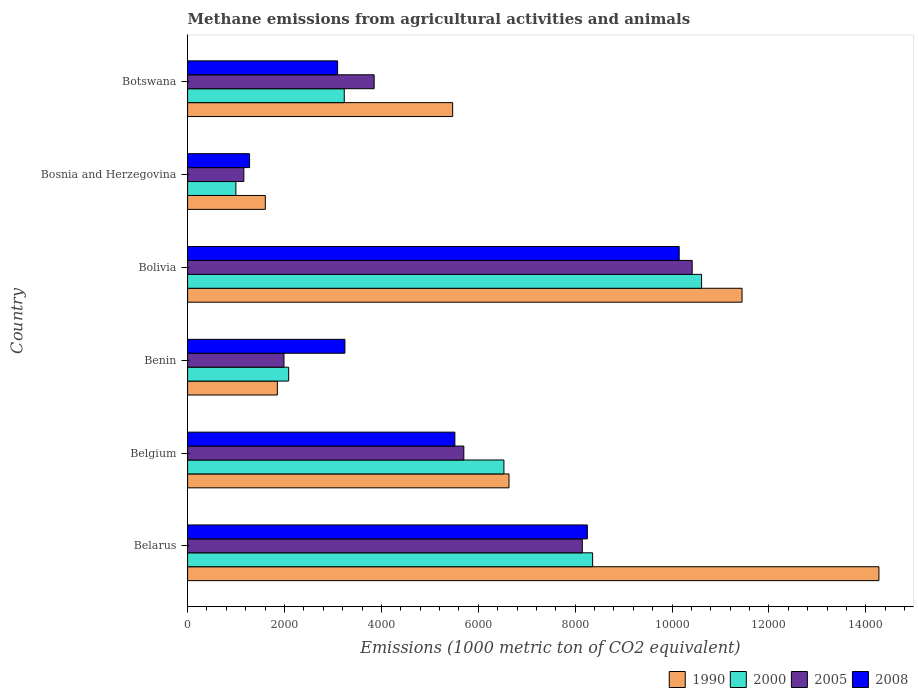Are the number of bars on each tick of the Y-axis equal?
Provide a short and direct response. Yes. How many bars are there on the 4th tick from the top?
Offer a very short reply. 4. What is the label of the 5th group of bars from the top?
Provide a succinct answer. Belgium. In how many cases, is the number of bars for a given country not equal to the number of legend labels?
Provide a succinct answer. 0. What is the amount of methane emitted in 2005 in Belarus?
Your response must be concise. 8147.7. Across all countries, what is the maximum amount of methane emitted in 2008?
Offer a terse response. 1.01e+04. Across all countries, what is the minimum amount of methane emitted in 2008?
Offer a very short reply. 1279.4. In which country was the amount of methane emitted in 1990 maximum?
Provide a short and direct response. Belarus. In which country was the amount of methane emitted in 2008 minimum?
Your response must be concise. Bosnia and Herzegovina. What is the total amount of methane emitted in 1990 in the graph?
Make the answer very short. 4.13e+04. What is the difference between the amount of methane emitted in 1990 in Benin and that in Bolivia?
Provide a succinct answer. -9592. What is the difference between the amount of methane emitted in 1990 in Bolivia and the amount of methane emitted in 2005 in Belgium?
Keep it short and to the point. 5743.2. What is the average amount of methane emitted in 2005 per country?
Your answer should be compact. 5211.05. What is the difference between the amount of methane emitted in 2005 and amount of methane emitted in 1990 in Belarus?
Ensure brevity in your answer.  -6122.6. What is the ratio of the amount of methane emitted in 2008 in Bolivia to that in Botswana?
Your answer should be compact. 3.28. Is the amount of methane emitted in 2008 in Belarus less than that in Bosnia and Herzegovina?
Your answer should be very brief. No. What is the difference between the highest and the second highest amount of methane emitted in 2008?
Your response must be concise. 1895.5. What is the difference between the highest and the lowest amount of methane emitted in 1990?
Your response must be concise. 1.27e+04. In how many countries, is the amount of methane emitted in 1990 greater than the average amount of methane emitted in 1990 taken over all countries?
Provide a succinct answer. 2. Is the sum of the amount of methane emitted in 1990 in Belarus and Belgium greater than the maximum amount of methane emitted in 2000 across all countries?
Offer a very short reply. Yes. What does the 3rd bar from the bottom in Benin represents?
Give a very brief answer. 2005. Is it the case that in every country, the sum of the amount of methane emitted in 2000 and amount of methane emitted in 1990 is greater than the amount of methane emitted in 2008?
Keep it short and to the point. Yes. How many countries are there in the graph?
Provide a succinct answer. 6. What is the difference between two consecutive major ticks on the X-axis?
Your answer should be compact. 2000. Does the graph contain any zero values?
Keep it short and to the point. No. Where does the legend appear in the graph?
Offer a very short reply. Bottom right. How are the legend labels stacked?
Offer a very short reply. Horizontal. What is the title of the graph?
Offer a very short reply. Methane emissions from agricultural activities and animals. Does "1980" appear as one of the legend labels in the graph?
Your answer should be very brief. No. What is the label or title of the X-axis?
Offer a terse response. Emissions (1000 metric ton of CO2 equivalent). What is the label or title of the Y-axis?
Your response must be concise. Country. What is the Emissions (1000 metric ton of CO2 equivalent) in 1990 in Belarus?
Keep it short and to the point. 1.43e+04. What is the Emissions (1000 metric ton of CO2 equivalent) of 2000 in Belarus?
Your answer should be very brief. 8360.4. What is the Emissions (1000 metric ton of CO2 equivalent) in 2005 in Belarus?
Offer a very short reply. 8147.7. What is the Emissions (1000 metric ton of CO2 equivalent) in 2008 in Belarus?
Your response must be concise. 8252. What is the Emissions (1000 metric ton of CO2 equivalent) of 1990 in Belgium?
Your answer should be very brief. 6634.3. What is the Emissions (1000 metric ton of CO2 equivalent) of 2000 in Belgium?
Offer a terse response. 6529.5. What is the Emissions (1000 metric ton of CO2 equivalent) in 2005 in Belgium?
Your response must be concise. 5701.8. What is the Emissions (1000 metric ton of CO2 equivalent) in 2008 in Belgium?
Give a very brief answer. 5517.1. What is the Emissions (1000 metric ton of CO2 equivalent) of 1990 in Benin?
Your answer should be very brief. 1853. What is the Emissions (1000 metric ton of CO2 equivalent) of 2000 in Benin?
Offer a very short reply. 2086.3. What is the Emissions (1000 metric ton of CO2 equivalent) in 2005 in Benin?
Your answer should be very brief. 1989.2. What is the Emissions (1000 metric ton of CO2 equivalent) of 2008 in Benin?
Ensure brevity in your answer.  3247.6. What is the Emissions (1000 metric ton of CO2 equivalent) of 1990 in Bolivia?
Offer a terse response. 1.14e+04. What is the Emissions (1000 metric ton of CO2 equivalent) in 2000 in Bolivia?
Give a very brief answer. 1.06e+04. What is the Emissions (1000 metric ton of CO2 equivalent) in 2005 in Bolivia?
Offer a very short reply. 1.04e+04. What is the Emissions (1000 metric ton of CO2 equivalent) in 2008 in Bolivia?
Keep it short and to the point. 1.01e+04. What is the Emissions (1000 metric ton of CO2 equivalent) of 1990 in Bosnia and Herzegovina?
Give a very brief answer. 1604.3. What is the Emissions (1000 metric ton of CO2 equivalent) of 2000 in Bosnia and Herzegovina?
Provide a succinct answer. 996.6. What is the Emissions (1000 metric ton of CO2 equivalent) in 2005 in Bosnia and Herzegovina?
Offer a very short reply. 1161.2. What is the Emissions (1000 metric ton of CO2 equivalent) of 2008 in Bosnia and Herzegovina?
Offer a terse response. 1279.4. What is the Emissions (1000 metric ton of CO2 equivalent) of 1990 in Botswana?
Your answer should be very brief. 5471.2. What is the Emissions (1000 metric ton of CO2 equivalent) in 2000 in Botswana?
Give a very brief answer. 3234. What is the Emissions (1000 metric ton of CO2 equivalent) in 2005 in Botswana?
Your response must be concise. 3850.6. What is the Emissions (1000 metric ton of CO2 equivalent) of 2008 in Botswana?
Make the answer very short. 3096.4. Across all countries, what is the maximum Emissions (1000 metric ton of CO2 equivalent) in 1990?
Your answer should be compact. 1.43e+04. Across all countries, what is the maximum Emissions (1000 metric ton of CO2 equivalent) in 2000?
Ensure brevity in your answer.  1.06e+04. Across all countries, what is the maximum Emissions (1000 metric ton of CO2 equivalent) in 2005?
Keep it short and to the point. 1.04e+04. Across all countries, what is the maximum Emissions (1000 metric ton of CO2 equivalent) in 2008?
Keep it short and to the point. 1.01e+04. Across all countries, what is the minimum Emissions (1000 metric ton of CO2 equivalent) of 1990?
Offer a very short reply. 1604.3. Across all countries, what is the minimum Emissions (1000 metric ton of CO2 equivalent) in 2000?
Keep it short and to the point. 996.6. Across all countries, what is the minimum Emissions (1000 metric ton of CO2 equivalent) in 2005?
Provide a succinct answer. 1161.2. Across all countries, what is the minimum Emissions (1000 metric ton of CO2 equivalent) in 2008?
Keep it short and to the point. 1279.4. What is the total Emissions (1000 metric ton of CO2 equivalent) of 1990 in the graph?
Provide a short and direct response. 4.13e+04. What is the total Emissions (1000 metric ton of CO2 equivalent) in 2000 in the graph?
Your answer should be very brief. 3.18e+04. What is the total Emissions (1000 metric ton of CO2 equivalent) of 2005 in the graph?
Provide a succinct answer. 3.13e+04. What is the total Emissions (1000 metric ton of CO2 equivalent) in 2008 in the graph?
Make the answer very short. 3.15e+04. What is the difference between the Emissions (1000 metric ton of CO2 equivalent) in 1990 in Belarus and that in Belgium?
Provide a short and direct response. 7636. What is the difference between the Emissions (1000 metric ton of CO2 equivalent) in 2000 in Belarus and that in Belgium?
Offer a very short reply. 1830.9. What is the difference between the Emissions (1000 metric ton of CO2 equivalent) in 2005 in Belarus and that in Belgium?
Your response must be concise. 2445.9. What is the difference between the Emissions (1000 metric ton of CO2 equivalent) of 2008 in Belarus and that in Belgium?
Your answer should be compact. 2734.9. What is the difference between the Emissions (1000 metric ton of CO2 equivalent) in 1990 in Belarus and that in Benin?
Make the answer very short. 1.24e+04. What is the difference between the Emissions (1000 metric ton of CO2 equivalent) of 2000 in Belarus and that in Benin?
Ensure brevity in your answer.  6274.1. What is the difference between the Emissions (1000 metric ton of CO2 equivalent) of 2005 in Belarus and that in Benin?
Make the answer very short. 6158.5. What is the difference between the Emissions (1000 metric ton of CO2 equivalent) in 2008 in Belarus and that in Benin?
Provide a succinct answer. 5004.4. What is the difference between the Emissions (1000 metric ton of CO2 equivalent) in 1990 in Belarus and that in Bolivia?
Ensure brevity in your answer.  2825.3. What is the difference between the Emissions (1000 metric ton of CO2 equivalent) in 2000 in Belarus and that in Bolivia?
Your answer should be compact. -2249.3. What is the difference between the Emissions (1000 metric ton of CO2 equivalent) in 2005 in Belarus and that in Bolivia?
Ensure brevity in your answer.  -2268.1. What is the difference between the Emissions (1000 metric ton of CO2 equivalent) of 2008 in Belarus and that in Bolivia?
Keep it short and to the point. -1895.5. What is the difference between the Emissions (1000 metric ton of CO2 equivalent) in 1990 in Belarus and that in Bosnia and Herzegovina?
Make the answer very short. 1.27e+04. What is the difference between the Emissions (1000 metric ton of CO2 equivalent) of 2000 in Belarus and that in Bosnia and Herzegovina?
Offer a terse response. 7363.8. What is the difference between the Emissions (1000 metric ton of CO2 equivalent) of 2005 in Belarus and that in Bosnia and Herzegovina?
Offer a very short reply. 6986.5. What is the difference between the Emissions (1000 metric ton of CO2 equivalent) in 2008 in Belarus and that in Bosnia and Herzegovina?
Your response must be concise. 6972.6. What is the difference between the Emissions (1000 metric ton of CO2 equivalent) of 1990 in Belarus and that in Botswana?
Your answer should be very brief. 8799.1. What is the difference between the Emissions (1000 metric ton of CO2 equivalent) in 2000 in Belarus and that in Botswana?
Your answer should be very brief. 5126.4. What is the difference between the Emissions (1000 metric ton of CO2 equivalent) of 2005 in Belarus and that in Botswana?
Your response must be concise. 4297.1. What is the difference between the Emissions (1000 metric ton of CO2 equivalent) of 2008 in Belarus and that in Botswana?
Provide a succinct answer. 5155.6. What is the difference between the Emissions (1000 metric ton of CO2 equivalent) of 1990 in Belgium and that in Benin?
Keep it short and to the point. 4781.3. What is the difference between the Emissions (1000 metric ton of CO2 equivalent) in 2000 in Belgium and that in Benin?
Ensure brevity in your answer.  4443.2. What is the difference between the Emissions (1000 metric ton of CO2 equivalent) of 2005 in Belgium and that in Benin?
Your response must be concise. 3712.6. What is the difference between the Emissions (1000 metric ton of CO2 equivalent) of 2008 in Belgium and that in Benin?
Give a very brief answer. 2269.5. What is the difference between the Emissions (1000 metric ton of CO2 equivalent) of 1990 in Belgium and that in Bolivia?
Your response must be concise. -4810.7. What is the difference between the Emissions (1000 metric ton of CO2 equivalent) of 2000 in Belgium and that in Bolivia?
Make the answer very short. -4080.2. What is the difference between the Emissions (1000 metric ton of CO2 equivalent) in 2005 in Belgium and that in Bolivia?
Give a very brief answer. -4714. What is the difference between the Emissions (1000 metric ton of CO2 equivalent) of 2008 in Belgium and that in Bolivia?
Provide a succinct answer. -4630.4. What is the difference between the Emissions (1000 metric ton of CO2 equivalent) of 1990 in Belgium and that in Bosnia and Herzegovina?
Ensure brevity in your answer.  5030. What is the difference between the Emissions (1000 metric ton of CO2 equivalent) in 2000 in Belgium and that in Bosnia and Herzegovina?
Provide a succinct answer. 5532.9. What is the difference between the Emissions (1000 metric ton of CO2 equivalent) of 2005 in Belgium and that in Bosnia and Herzegovina?
Provide a succinct answer. 4540.6. What is the difference between the Emissions (1000 metric ton of CO2 equivalent) of 2008 in Belgium and that in Bosnia and Herzegovina?
Provide a succinct answer. 4237.7. What is the difference between the Emissions (1000 metric ton of CO2 equivalent) in 1990 in Belgium and that in Botswana?
Your answer should be very brief. 1163.1. What is the difference between the Emissions (1000 metric ton of CO2 equivalent) in 2000 in Belgium and that in Botswana?
Keep it short and to the point. 3295.5. What is the difference between the Emissions (1000 metric ton of CO2 equivalent) of 2005 in Belgium and that in Botswana?
Your answer should be compact. 1851.2. What is the difference between the Emissions (1000 metric ton of CO2 equivalent) of 2008 in Belgium and that in Botswana?
Make the answer very short. 2420.7. What is the difference between the Emissions (1000 metric ton of CO2 equivalent) in 1990 in Benin and that in Bolivia?
Provide a succinct answer. -9592. What is the difference between the Emissions (1000 metric ton of CO2 equivalent) in 2000 in Benin and that in Bolivia?
Your answer should be compact. -8523.4. What is the difference between the Emissions (1000 metric ton of CO2 equivalent) of 2005 in Benin and that in Bolivia?
Give a very brief answer. -8426.6. What is the difference between the Emissions (1000 metric ton of CO2 equivalent) in 2008 in Benin and that in Bolivia?
Give a very brief answer. -6899.9. What is the difference between the Emissions (1000 metric ton of CO2 equivalent) of 1990 in Benin and that in Bosnia and Herzegovina?
Your response must be concise. 248.7. What is the difference between the Emissions (1000 metric ton of CO2 equivalent) in 2000 in Benin and that in Bosnia and Herzegovina?
Your answer should be very brief. 1089.7. What is the difference between the Emissions (1000 metric ton of CO2 equivalent) of 2005 in Benin and that in Bosnia and Herzegovina?
Make the answer very short. 828. What is the difference between the Emissions (1000 metric ton of CO2 equivalent) in 2008 in Benin and that in Bosnia and Herzegovina?
Provide a succinct answer. 1968.2. What is the difference between the Emissions (1000 metric ton of CO2 equivalent) of 1990 in Benin and that in Botswana?
Offer a very short reply. -3618.2. What is the difference between the Emissions (1000 metric ton of CO2 equivalent) in 2000 in Benin and that in Botswana?
Keep it short and to the point. -1147.7. What is the difference between the Emissions (1000 metric ton of CO2 equivalent) of 2005 in Benin and that in Botswana?
Provide a succinct answer. -1861.4. What is the difference between the Emissions (1000 metric ton of CO2 equivalent) of 2008 in Benin and that in Botswana?
Ensure brevity in your answer.  151.2. What is the difference between the Emissions (1000 metric ton of CO2 equivalent) of 1990 in Bolivia and that in Bosnia and Herzegovina?
Your answer should be compact. 9840.7. What is the difference between the Emissions (1000 metric ton of CO2 equivalent) of 2000 in Bolivia and that in Bosnia and Herzegovina?
Provide a succinct answer. 9613.1. What is the difference between the Emissions (1000 metric ton of CO2 equivalent) in 2005 in Bolivia and that in Bosnia and Herzegovina?
Ensure brevity in your answer.  9254.6. What is the difference between the Emissions (1000 metric ton of CO2 equivalent) in 2008 in Bolivia and that in Bosnia and Herzegovina?
Give a very brief answer. 8868.1. What is the difference between the Emissions (1000 metric ton of CO2 equivalent) in 1990 in Bolivia and that in Botswana?
Your response must be concise. 5973.8. What is the difference between the Emissions (1000 metric ton of CO2 equivalent) in 2000 in Bolivia and that in Botswana?
Ensure brevity in your answer.  7375.7. What is the difference between the Emissions (1000 metric ton of CO2 equivalent) in 2005 in Bolivia and that in Botswana?
Your answer should be very brief. 6565.2. What is the difference between the Emissions (1000 metric ton of CO2 equivalent) in 2008 in Bolivia and that in Botswana?
Provide a short and direct response. 7051.1. What is the difference between the Emissions (1000 metric ton of CO2 equivalent) of 1990 in Bosnia and Herzegovina and that in Botswana?
Ensure brevity in your answer.  -3866.9. What is the difference between the Emissions (1000 metric ton of CO2 equivalent) of 2000 in Bosnia and Herzegovina and that in Botswana?
Ensure brevity in your answer.  -2237.4. What is the difference between the Emissions (1000 metric ton of CO2 equivalent) in 2005 in Bosnia and Herzegovina and that in Botswana?
Keep it short and to the point. -2689.4. What is the difference between the Emissions (1000 metric ton of CO2 equivalent) of 2008 in Bosnia and Herzegovina and that in Botswana?
Your response must be concise. -1817. What is the difference between the Emissions (1000 metric ton of CO2 equivalent) in 1990 in Belarus and the Emissions (1000 metric ton of CO2 equivalent) in 2000 in Belgium?
Make the answer very short. 7740.8. What is the difference between the Emissions (1000 metric ton of CO2 equivalent) of 1990 in Belarus and the Emissions (1000 metric ton of CO2 equivalent) of 2005 in Belgium?
Ensure brevity in your answer.  8568.5. What is the difference between the Emissions (1000 metric ton of CO2 equivalent) of 1990 in Belarus and the Emissions (1000 metric ton of CO2 equivalent) of 2008 in Belgium?
Ensure brevity in your answer.  8753.2. What is the difference between the Emissions (1000 metric ton of CO2 equivalent) in 2000 in Belarus and the Emissions (1000 metric ton of CO2 equivalent) in 2005 in Belgium?
Provide a short and direct response. 2658.6. What is the difference between the Emissions (1000 metric ton of CO2 equivalent) of 2000 in Belarus and the Emissions (1000 metric ton of CO2 equivalent) of 2008 in Belgium?
Give a very brief answer. 2843.3. What is the difference between the Emissions (1000 metric ton of CO2 equivalent) in 2005 in Belarus and the Emissions (1000 metric ton of CO2 equivalent) in 2008 in Belgium?
Keep it short and to the point. 2630.6. What is the difference between the Emissions (1000 metric ton of CO2 equivalent) in 1990 in Belarus and the Emissions (1000 metric ton of CO2 equivalent) in 2000 in Benin?
Give a very brief answer. 1.22e+04. What is the difference between the Emissions (1000 metric ton of CO2 equivalent) in 1990 in Belarus and the Emissions (1000 metric ton of CO2 equivalent) in 2005 in Benin?
Ensure brevity in your answer.  1.23e+04. What is the difference between the Emissions (1000 metric ton of CO2 equivalent) in 1990 in Belarus and the Emissions (1000 metric ton of CO2 equivalent) in 2008 in Benin?
Your answer should be very brief. 1.10e+04. What is the difference between the Emissions (1000 metric ton of CO2 equivalent) of 2000 in Belarus and the Emissions (1000 metric ton of CO2 equivalent) of 2005 in Benin?
Make the answer very short. 6371.2. What is the difference between the Emissions (1000 metric ton of CO2 equivalent) of 2000 in Belarus and the Emissions (1000 metric ton of CO2 equivalent) of 2008 in Benin?
Offer a terse response. 5112.8. What is the difference between the Emissions (1000 metric ton of CO2 equivalent) of 2005 in Belarus and the Emissions (1000 metric ton of CO2 equivalent) of 2008 in Benin?
Your answer should be very brief. 4900.1. What is the difference between the Emissions (1000 metric ton of CO2 equivalent) of 1990 in Belarus and the Emissions (1000 metric ton of CO2 equivalent) of 2000 in Bolivia?
Offer a terse response. 3660.6. What is the difference between the Emissions (1000 metric ton of CO2 equivalent) in 1990 in Belarus and the Emissions (1000 metric ton of CO2 equivalent) in 2005 in Bolivia?
Make the answer very short. 3854.5. What is the difference between the Emissions (1000 metric ton of CO2 equivalent) in 1990 in Belarus and the Emissions (1000 metric ton of CO2 equivalent) in 2008 in Bolivia?
Give a very brief answer. 4122.8. What is the difference between the Emissions (1000 metric ton of CO2 equivalent) in 2000 in Belarus and the Emissions (1000 metric ton of CO2 equivalent) in 2005 in Bolivia?
Make the answer very short. -2055.4. What is the difference between the Emissions (1000 metric ton of CO2 equivalent) of 2000 in Belarus and the Emissions (1000 metric ton of CO2 equivalent) of 2008 in Bolivia?
Your answer should be very brief. -1787.1. What is the difference between the Emissions (1000 metric ton of CO2 equivalent) of 2005 in Belarus and the Emissions (1000 metric ton of CO2 equivalent) of 2008 in Bolivia?
Make the answer very short. -1999.8. What is the difference between the Emissions (1000 metric ton of CO2 equivalent) in 1990 in Belarus and the Emissions (1000 metric ton of CO2 equivalent) in 2000 in Bosnia and Herzegovina?
Your answer should be very brief. 1.33e+04. What is the difference between the Emissions (1000 metric ton of CO2 equivalent) in 1990 in Belarus and the Emissions (1000 metric ton of CO2 equivalent) in 2005 in Bosnia and Herzegovina?
Provide a short and direct response. 1.31e+04. What is the difference between the Emissions (1000 metric ton of CO2 equivalent) of 1990 in Belarus and the Emissions (1000 metric ton of CO2 equivalent) of 2008 in Bosnia and Herzegovina?
Your answer should be compact. 1.30e+04. What is the difference between the Emissions (1000 metric ton of CO2 equivalent) in 2000 in Belarus and the Emissions (1000 metric ton of CO2 equivalent) in 2005 in Bosnia and Herzegovina?
Your answer should be very brief. 7199.2. What is the difference between the Emissions (1000 metric ton of CO2 equivalent) in 2000 in Belarus and the Emissions (1000 metric ton of CO2 equivalent) in 2008 in Bosnia and Herzegovina?
Your answer should be compact. 7081. What is the difference between the Emissions (1000 metric ton of CO2 equivalent) of 2005 in Belarus and the Emissions (1000 metric ton of CO2 equivalent) of 2008 in Bosnia and Herzegovina?
Keep it short and to the point. 6868.3. What is the difference between the Emissions (1000 metric ton of CO2 equivalent) of 1990 in Belarus and the Emissions (1000 metric ton of CO2 equivalent) of 2000 in Botswana?
Your answer should be very brief. 1.10e+04. What is the difference between the Emissions (1000 metric ton of CO2 equivalent) in 1990 in Belarus and the Emissions (1000 metric ton of CO2 equivalent) in 2005 in Botswana?
Keep it short and to the point. 1.04e+04. What is the difference between the Emissions (1000 metric ton of CO2 equivalent) of 1990 in Belarus and the Emissions (1000 metric ton of CO2 equivalent) of 2008 in Botswana?
Your response must be concise. 1.12e+04. What is the difference between the Emissions (1000 metric ton of CO2 equivalent) in 2000 in Belarus and the Emissions (1000 metric ton of CO2 equivalent) in 2005 in Botswana?
Offer a terse response. 4509.8. What is the difference between the Emissions (1000 metric ton of CO2 equivalent) of 2000 in Belarus and the Emissions (1000 metric ton of CO2 equivalent) of 2008 in Botswana?
Provide a succinct answer. 5264. What is the difference between the Emissions (1000 metric ton of CO2 equivalent) of 2005 in Belarus and the Emissions (1000 metric ton of CO2 equivalent) of 2008 in Botswana?
Give a very brief answer. 5051.3. What is the difference between the Emissions (1000 metric ton of CO2 equivalent) in 1990 in Belgium and the Emissions (1000 metric ton of CO2 equivalent) in 2000 in Benin?
Keep it short and to the point. 4548. What is the difference between the Emissions (1000 metric ton of CO2 equivalent) of 1990 in Belgium and the Emissions (1000 metric ton of CO2 equivalent) of 2005 in Benin?
Provide a succinct answer. 4645.1. What is the difference between the Emissions (1000 metric ton of CO2 equivalent) in 1990 in Belgium and the Emissions (1000 metric ton of CO2 equivalent) in 2008 in Benin?
Your answer should be very brief. 3386.7. What is the difference between the Emissions (1000 metric ton of CO2 equivalent) of 2000 in Belgium and the Emissions (1000 metric ton of CO2 equivalent) of 2005 in Benin?
Make the answer very short. 4540.3. What is the difference between the Emissions (1000 metric ton of CO2 equivalent) of 2000 in Belgium and the Emissions (1000 metric ton of CO2 equivalent) of 2008 in Benin?
Provide a succinct answer. 3281.9. What is the difference between the Emissions (1000 metric ton of CO2 equivalent) of 2005 in Belgium and the Emissions (1000 metric ton of CO2 equivalent) of 2008 in Benin?
Offer a terse response. 2454.2. What is the difference between the Emissions (1000 metric ton of CO2 equivalent) of 1990 in Belgium and the Emissions (1000 metric ton of CO2 equivalent) of 2000 in Bolivia?
Your response must be concise. -3975.4. What is the difference between the Emissions (1000 metric ton of CO2 equivalent) of 1990 in Belgium and the Emissions (1000 metric ton of CO2 equivalent) of 2005 in Bolivia?
Make the answer very short. -3781.5. What is the difference between the Emissions (1000 metric ton of CO2 equivalent) of 1990 in Belgium and the Emissions (1000 metric ton of CO2 equivalent) of 2008 in Bolivia?
Offer a terse response. -3513.2. What is the difference between the Emissions (1000 metric ton of CO2 equivalent) of 2000 in Belgium and the Emissions (1000 metric ton of CO2 equivalent) of 2005 in Bolivia?
Ensure brevity in your answer.  -3886.3. What is the difference between the Emissions (1000 metric ton of CO2 equivalent) of 2000 in Belgium and the Emissions (1000 metric ton of CO2 equivalent) of 2008 in Bolivia?
Make the answer very short. -3618. What is the difference between the Emissions (1000 metric ton of CO2 equivalent) of 2005 in Belgium and the Emissions (1000 metric ton of CO2 equivalent) of 2008 in Bolivia?
Provide a succinct answer. -4445.7. What is the difference between the Emissions (1000 metric ton of CO2 equivalent) in 1990 in Belgium and the Emissions (1000 metric ton of CO2 equivalent) in 2000 in Bosnia and Herzegovina?
Ensure brevity in your answer.  5637.7. What is the difference between the Emissions (1000 metric ton of CO2 equivalent) in 1990 in Belgium and the Emissions (1000 metric ton of CO2 equivalent) in 2005 in Bosnia and Herzegovina?
Offer a very short reply. 5473.1. What is the difference between the Emissions (1000 metric ton of CO2 equivalent) of 1990 in Belgium and the Emissions (1000 metric ton of CO2 equivalent) of 2008 in Bosnia and Herzegovina?
Provide a succinct answer. 5354.9. What is the difference between the Emissions (1000 metric ton of CO2 equivalent) in 2000 in Belgium and the Emissions (1000 metric ton of CO2 equivalent) in 2005 in Bosnia and Herzegovina?
Give a very brief answer. 5368.3. What is the difference between the Emissions (1000 metric ton of CO2 equivalent) in 2000 in Belgium and the Emissions (1000 metric ton of CO2 equivalent) in 2008 in Bosnia and Herzegovina?
Provide a short and direct response. 5250.1. What is the difference between the Emissions (1000 metric ton of CO2 equivalent) in 2005 in Belgium and the Emissions (1000 metric ton of CO2 equivalent) in 2008 in Bosnia and Herzegovina?
Offer a very short reply. 4422.4. What is the difference between the Emissions (1000 metric ton of CO2 equivalent) in 1990 in Belgium and the Emissions (1000 metric ton of CO2 equivalent) in 2000 in Botswana?
Your response must be concise. 3400.3. What is the difference between the Emissions (1000 metric ton of CO2 equivalent) in 1990 in Belgium and the Emissions (1000 metric ton of CO2 equivalent) in 2005 in Botswana?
Your answer should be compact. 2783.7. What is the difference between the Emissions (1000 metric ton of CO2 equivalent) of 1990 in Belgium and the Emissions (1000 metric ton of CO2 equivalent) of 2008 in Botswana?
Provide a short and direct response. 3537.9. What is the difference between the Emissions (1000 metric ton of CO2 equivalent) in 2000 in Belgium and the Emissions (1000 metric ton of CO2 equivalent) in 2005 in Botswana?
Make the answer very short. 2678.9. What is the difference between the Emissions (1000 metric ton of CO2 equivalent) of 2000 in Belgium and the Emissions (1000 metric ton of CO2 equivalent) of 2008 in Botswana?
Offer a terse response. 3433.1. What is the difference between the Emissions (1000 metric ton of CO2 equivalent) of 2005 in Belgium and the Emissions (1000 metric ton of CO2 equivalent) of 2008 in Botswana?
Provide a succinct answer. 2605.4. What is the difference between the Emissions (1000 metric ton of CO2 equivalent) of 1990 in Benin and the Emissions (1000 metric ton of CO2 equivalent) of 2000 in Bolivia?
Your answer should be very brief. -8756.7. What is the difference between the Emissions (1000 metric ton of CO2 equivalent) of 1990 in Benin and the Emissions (1000 metric ton of CO2 equivalent) of 2005 in Bolivia?
Your response must be concise. -8562.8. What is the difference between the Emissions (1000 metric ton of CO2 equivalent) in 1990 in Benin and the Emissions (1000 metric ton of CO2 equivalent) in 2008 in Bolivia?
Ensure brevity in your answer.  -8294.5. What is the difference between the Emissions (1000 metric ton of CO2 equivalent) of 2000 in Benin and the Emissions (1000 metric ton of CO2 equivalent) of 2005 in Bolivia?
Offer a terse response. -8329.5. What is the difference between the Emissions (1000 metric ton of CO2 equivalent) of 2000 in Benin and the Emissions (1000 metric ton of CO2 equivalent) of 2008 in Bolivia?
Your answer should be compact. -8061.2. What is the difference between the Emissions (1000 metric ton of CO2 equivalent) in 2005 in Benin and the Emissions (1000 metric ton of CO2 equivalent) in 2008 in Bolivia?
Your response must be concise. -8158.3. What is the difference between the Emissions (1000 metric ton of CO2 equivalent) in 1990 in Benin and the Emissions (1000 metric ton of CO2 equivalent) in 2000 in Bosnia and Herzegovina?
Make the answer very short. 856.4. What is the difference between the Emissions (1000 metric ton of CO2 equivalent) of 1990 in Benin and the Emissions (1000 metric ton of CO2 equivalent) of 2005 in Bosnia and Herzegovina?
Offer a terse response. 691.8. What is the difference between the Emissions (1000 metric ton of CO2 equivalent) in 1990 in Benin and the Emissions (1000 metric ton of CO2 equivalent) in 2008 in Bosnia and Herzegovina?
Keep it short and to the point. 573.6. What is the difference between the Emissions (1000 metric ton of CO2 equivalent) of 2000 in Benin and the Emissions (1000 metric ton of CO2 equivalent) of 2005 in Bosnia and Herzegovina?
Keep it short and to the point. 925.1. What is the difference between the Emissions (1000 metric ton of CO2 equivalent) in 2000 in Benin and the Emissions (1000 metric ton of CO2 equivalent) in 2008 in Bosnia and Herzegovina?
Keep it short and to the point. 806.9. What is the difference between the Emissions (1000 metric ton of CO2 equivalent) in 2005 in Benin and the Emissions (1000 metric ton of CO2 equivalent) in 2008 in Bosnia and Herzegovina?
Provide a short and direct response. 709.8. What is the difference between the Emissions (1000 metric ton of CO2 equivalent) in 1990 in Benin and the Emissions (1000 metric ton of CO2 equivalent) in 2000 in Botswana?
Your response must be concise. -1381. What is the difference between the Emissions (1000 metric ton of CO2 equivalent) of 1990 in Benin and the Emissions (1000 metric ton of CO2 equivalent) of 2005 in Botswana?
Provide a short and direct response. -1997.6. What is the difference between the Emissions (1000 metric ton of CO2 equivalent) in 1990 in Benin and the Emissions (1000 metric ton of CO2 equivalent) in 2008 in Botswana?
Your response must be concise. -1243.4. What is the difference between the Emissions (1000 metric ton of CO2 equivalent) of 2000 in Benin and the Emissions (1000 metric ton of CO2 equivalent) of 2005 in Botswana?
Keep it short and to the point. -1764.3. What is the difference between the Emissions (1000 metric ton of CO2 equivalent) of 2000 in Benin and the Emissions (1000 metric ton of CO2 equivalent) of 2008 in Botswana?
Provide a short and direct response. -1010.1. What is the difference between the Emissions (1000 metric ton of CO2 equivalent) in 2005 in Benin and the Emissions (1000 metric ton of CO2 equivalent) in 2008 in Botswana?
Make the answer very short. -1107.2. What is the difference between the Emissions (1000 metric ton of CO2 equivalent) of 1990 in Bolivia and the Emissions (1000 metric ton of CO2 equivalent) of 2000 in Bosnia and Herzegovina?
Make the answer very short. 1.04e+04. What is the difference between the Emissions (1000 metric ton of CO2 equivalent) in 1990 in Bolivia and the Emissions (1000 metric ton of CO2 equivalent) in 2005 in Bosnia and Herzegovina?
Make the answer very short. 1.03e+04. What is the difference between the Emissions (1000 metric ton of CO2 equivalent) in 1990 in Bolivia and the Emissions (1000 metric ton of CO2 equivalent) in 2008 in Bosnia and Herzegovina?
Offer a terse response. 1.02e+04. What is the difference between the Emissions (1000 metric ton of CO2 equivalent) of 2000 in Bolivia and the Emissions (1000 metric ton of CO2 equivalent) of 2005 in Bosnia and Herzegovina?
Give a very brief answer. 9448.5. What is the difference between the Emissions (1000 metric ton of CO2 equivalent) in 2000 in Bolivia and the Emissions (1000 metric ton of CO2 equivalent) in 2008 in Bosnia and Herzegovina?
Give a very brief answer. 9330.3. What is the difference between the Emissions (1000 metric ton of CO2 equivalent) in 2005 in Bolivia and the Emissions (1000 metric ton of CO2 equivalent) in 2008 in Bosnia and Herzegovina?
Your response must be concise. 9136.4. What is the difference between the Emissions (1000 metric ton of CO2 equivalent) in 1990 in Bolivia and the Emissions (1000 metric ton of CO2 equivalent) in 2000 in Botswana?
Your answer should be very brief. 8211. What is the difference between the Emissions (1000 metric ton of CO2 equivalent) of 1990 in Bolivia and the Emissions (1000 metric ton of CO2 equivalent) of 2005 in Botswana?
Provide a succinct answer. 7594.4. What is the difference between the Emissions (1000 metric ton of CO2 equivalent) in 1990 in Bolivia and the Emissions (1000 metric ton of CO2 equivalent) in 2008 in Botswana?
Give a very brief answer. 8348.6. What is the difference between the Emissions (1000 metric ton of CO2 equivalent) in 2000 in Bolivia and the Emissions (1000 metric ton of CO2 equivalent) in 2005 in Botswana?
Keep it short and to the point. 6759.1. What is the difference between the Emissions (1000 metric ton of CO2 equivalent) in 2000 in Bolivia and the Emissions (1000 metric ton of CO2 equivalent) in 2008 in Botswana?
Keep it short and to the point. 7513.3. What is the difference between the Emissions (1000 metric ton of CO2 equivalent) of 2005 in Bolivia and the Emissions (1000 metric ton of CO2 equivalent) of 2008 in Botswana?
Keep it short and to the point. 7319.4. What is the difference between the Emissions (1000 metric ton of CO2 equivalent) in 1990 in Bosnia and Herzegovina and the Emissions (1000 metric ton of CO2 equivalent) in 2000 in Botswana?
Offer a very short reply. -1629.7. What is the difference between the Emissions (1000 metric ton of CO2 equivalent) of 1990 in Bosnia and Herzegovina and the Emissions (1000 metric ton of CO2 equivalent) of 2005 in Botswana?
Your response must be concise. -2246.3. What is the difference between the Emissions (1000 metric ton of CO2 equivalent) of 1990 in Bosnia and Herzegovina and the Emissions (1000 metric ton of CO2 equivalent) of 2008 in Botswana?
Provide a short and direct response. -1492.1. What is the difference between the Emissions (1000 metric ton of CO2 equivalent) in 2000 in Bosnia and Herzegovina and the Emissions (1000 metric ton of CO2 equivalent) in 2005 in Botswana?
Provide a short and direct response. -2854. What is the difference between the Emissions (1000 metric ton of CO2 equivalent) in 2000 in Bosnia and Herzegovina and the Emissions (1000 metric ton of CO2 equivalent) in 2008 in Botswana?
Offer a terse response. -2099.8. What is the difference between the Emissions (1000 metric ton of CO2 equivalent) in 2005 in Bosnia and Herzegovina and the Emissions (1000 metric ton of CO2 equivalent) in 2008 in Botswana?
Your answer should be very brief. -1935.2. What is the average Emissions (1000 metric ton of CO2 equivalent) in 1990 per country?
Offer a terse response. 6879.68. What is the average Emissions (1000 metric ton of CO2 equivalent) in 2000 per country?
Your answer should be very brief. 5302.75. What is the average Emissions (1000 metric ton of CO2 equivalent) of 2005 per country?
Your answer should be very brief. 5211.05. What is the average Emissions (1000 metric ton of CO2 equivalent) of 2008 per country?
Your answer should be compact. 5256.67. What is the difference between the Emissions (1000 metric ton of CO2 equivalent) of 1990 and Emissions (1000 metric ton of CO2 equivalent) of 2000 in Belarus?
Your answer should be very brief. 5909.9. What is the difference between the Emissions (1000 metric ton of CO2 equivalent) in 1990 and Emissions (1000 metric ton of CO2 equivalent) in 2005 in Belarus?
Ensure brevity in your answer.  6122.6. What is the difference between the Emissions (1000 metric ton of CO2 equivalent) in 1990 and Emissions (1000 metric ton of CO2 equivalent) in 2008 in Belarus?
Your response must be concise. 6018.3. What is the difference between the Emissions (1000 metric ton of CO2 equivalent) of 2000 and Emissions (1000 metric ton of CO2 equivalent) of 2005 in Belarus?
Offer a terse response. 212.7. What is the difference between the Emissions (1000 metric ton of CO2 equivalent) in 2000 and Emissions (1000 metric ton of CO2 equivalent) in 2008 in Belarus?
Your answer should be compact. 108.4. What is the difference between the Emissions (1000 metric ton of CO2 equivalent) in 2005 and Emissions (1000 metric ton of CO2 equivalent) in 2008 in Belarus?
Ensure brevity in your answer.  -104.3. What is the difference between the Emissions (1000 metric ton of CO2 equivalent) of 1990 and Emissions (1000 metric ton of CO2 equivalent) of 2000 in Belgium?
Your answer should be very brief. 104.8. What is the difference between the Emissions (1000 metric ton of CO2 equivalent) of 1990 and Emissions (1000 metric ton of CO2 equivalent) of 2005 in Belgium?
Keep it short and to the point. 932.5. What is the difference between the Emissions (1000 metric ton of CO2 equivalent) in 1990 and Emissions (1000 metric ton of CO2 equivalent) in 2008 in Belgium?
Offer a terse response. 1117.2. What is the difference between the Emissions (1000 metric ton of CO2 equivalent) in 2000 and Emissions (1000 metric ton of CO2 equivalent) in 2005 in Belgium?
Give a very brief answer. 827.7. What is the difference between the Emissions (1000 metric ton of CO2 equivalent) of 2000 and Emissions (1000 metric ton of CO2 equivalent) of 2008 in Belgium?
Give a very brief answer. 1012.4. What is the difference between the Emissions (1000 metric ton of CO2 equivalent) in 2005 and Emissions (1000 metric ton of CO2 equivalent) in 2008 in Belgium?
Keep it short and to the point. 184.7. What is the difference between the Emissions (1000 metric ton of CO2 equivalent) in 1990 and Emissions (1000 metric ton of CO2 equivalent) in 2000 in Benin?
Give a very brief answer. -233.3. What is the difference between the Emissions (1000 metric ton of CO2 equivalent) in 1990 and Emissions (1000 metric ton of CO2 equivalent) in 2005 in Benin?
Offer a very short reply. -136.2. What is the difference between the Emissions (1000 metric ton of CO2 equivalent) in 1990 and Emissions (1000 metric ton of CO2 equivalent) in 2008 in Benin?
Your response must be concise. -1394.6. What is the difference between the Emissions (1000 metric ton of CO2 equivalent) of 2000 and Emissions (1000 metric ton of CO2 equivalent) of 2005 in Benin?
Keep it short and to the point. 97.1. What is the difference between the Emissions (1000 metric ton of CO2 equivalent) of 2000 and Emissions (1000 metric ton of CO2 equivalent) of 2008 in Benin?
Offer a very short reply. -1161.3. What is the difference between the Emissions (1000 metric ton of CO2 equivalent) in 2005 and Emissions (1000 metric ton of CO2 equivalent) in 2008 in Benin?
Give a very brief answer. -1258.4. What is the difference between the Emissions (1000 metric ton of CO2 equivalent) of 1990 and Emissions (1000 metric ton of CO2 equivalent) of 2000 in Bolivia?
Offer a very short reply. 835.3. What is the difference between the Emissions (1000 metric ton of CO2 equivalent) in 1990 and Emissions (1000 metric ton of CO2 equivalent) in 2005 in Bolivia?
Provide a short and direct response. 1029.2. What is the difference between the Emissions (1000 metric ton of CO2 equivalent) in 1990 and Emissions (1000 metric ton of CO2 equivalent) in 2008 in Bolivia?
Provide a succinct answer. 1297.5. What is the difference between the Emissions (1000 metric ton of CO2 equivalent) of 2000 and Emissions (1000 metric ton of CO2 equivalent) of 2005 in Bolivia?
Your answer should be compact. 193.9. What is the difference between the Emissions (1000 metric ton of CO2 equivalent) in 2000 and Emissions (1000 metric ton of CO2 equivalent) in 2008 in Bolivia?
Provide a succinct answer. 462.2. What is the difference between the Emissions (1000 metric ton of CO2 equivalent) in 2005 and Emissions (1000 metric ton of CO2 equivalent) in 2008 in Bolivia?
Provide a succinct answer. 268.3. What is the difference between the Emissions (1000 metric ton of CO2 equivalent) of 1990 and Emissions (1000 metric ton of CO2 equivalent) of 2000 in Bosnia and Herzegovina?
Keep it short and to the point. 607.7. What is the difference between the Emissions (1000 metric ton of CO2 equivalent) of 1990 and Emissions (1000 metric ton of CO2 equivalent) of 2005 in Bosnia and Herzegovina?
Your response must be concise. 443.1. What is the difference between the Emissions (1000 metric ton of CO2 equivalent) in 1990 and Emissions (1000 metric ton of CO2 equivalent) in 2008 in Bosnia and Herzegovina?
Your answer should be compact. 324.9. What is the difference between the Emissions (1000 metric ton of CO2 equivalent) of 2000 and Emissions (1000 metric ton of CO2 equivalent) of 2005 in Bosnia and Herzegovina?
Keep it short and to the point. -164.6. What is the difference between the Emissions (1000 metric ton of CO2 equivalent) in 2000 and Emissions (1000 metric ton of CO2 equivalent) in 2008 in Bosnia and Herzegovina?
Offer a very short reply. -282.8. What is the difference between the Emissions (1000 metric ton of CO2 equivalent) in 2005 and Emissions (1000 metric ton of CO2 equivalent) in 2008 in Bosnia and Herzegovina?
Ensure brevity in your answer.  -118.2. What is the difference between the Emissions (1000 metric ton of CO2 equivalent) of 1990 and Emissions (1000 metric ton of CO2 equivalent) of 2000 in Botswana?
Provide a succinct answer. 2237.2. What is the difference between the Emissions (1000 metric ton of CO2 equivalent) in 1990 and Emissions (1000 metric ton of CO2 equivalent) in 2005 in Botswana?
Offer a very short reply. 1620.6. What is the difference between the Emissions (1000 metric ton of CO2 equivalent) in 1990 and Emissions (1000 metric ton of CO2 equivalent) in 2008 in Botswana?
Give a very brief answer. 2374.8. What is the difference between the Emissions (1000 metric ton of CO2 equivalent) of 2000 and Emissions (1000 metric ton of CO2 equivalent) of 2005 in Botswana?
Provide a short and direct response. -616.6. What is the difference between the Emissions (1000 metric ton of CO2 equivalent) of 2000 and Emissions (1000 metric ton of CO2 equivalent) of 2008 in Botswana?
Provide a succinct answer. 137.6. What is the difference between the Emissions (1000 metric ton of CO2 equivalent) of 2005 and Emissions (1000 metric ton of CO2 equivalent) of 2008 in Botswana?
Offer a terse response. 754.2. What is the ratio of the Emissions (1000 metric ton of CO2 equivalent) of 1990 in Belarus to that in Belgium?
Your response must be concise. 2.15. What is the ratio of the Emissions (1000 metric ton of CO2 equivalent) of 2000 in Belarus to that in Belgium?
Offer a terse response. 1.28. What is the ratio of the Emissions (1000 metric ton of CO2 equivalent) of 2005 in Belarus to that in Belgium?
Your response must be concise. 1.43. What is the ratio of the Emissions (1000 metric ton of CO2 equivalent) in 2008 in Belarus to that in Belgium?
Make the answer very short. 1.5. What is the ratio of the Emissions (1000 metric ton of CO2 equivalent) in 1990 in Belarus to that in Benin?
Offer a terse response. 7.7. What is the ratio of the Emissions (1000 metric ton of CO2 equivalent) of 2000 in Belarus to that in Benin?
Provide a short and direct response. 4.01. What is the ratio of the Emissions (1000 metric ton of CO2 equivalent) in 2005 in Belarus to that in Benin?
Keep it short and to the point. 4.1. What is the ratio of the Emissions (1000 metric ton of CO2 equivalent) of 2008 in Belarus to that in Benin?
Give a very brief answer. 2.54. What is the ratio of the Emissions (1000 metric ton of CO2 equivalent) in 1990 in Belarus to that in Bolivia?
Provide a short and direct response. 1.25. What is the ratio of the Emissions (1000 metric ton of CO2 equivalent) in 2000 in Belarus to that in Bolivia?
Your answer should be very brief. 0.79. What is the ratio of the Emissions (1000 metric ton of CO2 equivalent) of 2005 in Belarus to that in Bolivia?
Offer a very short reply. 0.78. What is the ratio of the Emissions (1000 metric ton of CO2 equivalent) in 2008 in Belarus to that in Bolivia?
Provide a short and direct response. 0.81. What is the ratio of the Emissions (1000 metric ton of CO2 equivalent) in 1990 in Belarus to that in Bosnia and Herzegovina?
Provide a short and direct response. 8.89. What is the ratio of the Emissions (1000 metric ton of CO2 equivalent) in 2000 in Belarus to that in Bosnia and Herzegovina?
Give a very brief answer. 8.39. What is the ratio of the Emissions (1000 metric ton of CO2 equivalent) in 2005 in Belarus to that in Bosnia and Herzegovina?
Your response must be concise. 7.02. What is the ratio of the Emissions (1000 metric ton of CO2 equivalent) in 2008 in Belarus to that in Bosnia and Herzegovina?
Your response must be concise. 6.45. What is the ratio of the Emissions (1000 metric ton of CO2 equivalent) in 1990 in Belarus to that in Botswana?
Give a very brief answer. 2.61. What is the ratio of the Emissions (1000 metric ton of CO2 equivalent) in 2000 in Belarus to that in Botswana?
Your answer should be compact. 2.59. What is the ratio of the Emissions (1000 metric ton of CO2 equivalent) in 2005 in Belarus to that in Botswana?
Your answer should be compact. 2.12. What is the ratio of the Emissions (1000 metric ton of CO2 equivalent) in 2008 in Belarus to that in Botswana?
Your answer should be compact. 2.67. What is the ratio of the Emissions (1000 metric ton of CO2 equivalent) of 1990 in Belgium to that in Benin?
Offer a terse response. 3.58. What is the ratio of the Emissions (1000 metric ton of CO2 equivalent) of 2000 in Belgium to that in Benin?
Offer a terse response. 3.13. What is the ratio of the Emissions (1000 metric ton of CO2 equivalent) in 2005 in Belgium to that in Benin?
Provide a short and direct response. 2.87. What is the ratio of the Emissions (1000 metric ton of CO2 equivalent) in 2008 in Belgium to that in Benin?
Your answer should be compact. 1.7. What is the ratio of the Emissions (1000 metric ton of CO2 equivalent) in 1990 in Belgium to that in Bolivia?
Provide a short and direct response. 0.58. What is the ratio of the Emissions (1000 metric ton of CO2 equivalent) of 2000 in Belgium to that in Bolivia?
Give a very brief answer. 0.62. What is the ratio of the Emissions (1000 metric ton of CO2 equivalent) of 2005 in Belgium to that in Bolivia?
Ensure brevity in your answer.  0.55. What is the ratio of the Emissions (1000 metric ton of CO2 equivalent) in 2008 in Belgium to that in Bolivia?
Give a very brief answer. 0.54. What is the ratio of the Emissions (1000 metric ton of CO2 equivalent) of 1990 in Belgium to that in Bosnia and Herzegovina?
Your answer should be very brief. 4.14. What is the ratio of the Emissions (1000 metric ton of CO2 equivalent) of 2000 in Belgium to that in Bosnia and Herzegovina?
Keep it short and to the point. 6.55. What is the ratio of the Emissions (1000 metric ton of CO2 equivalent) of 2005 in Belgium to that in Bosnia and Herzegovina?
Offer a very short reply. 4.91. What is the ratio of the Emissions (1000 metric ton of CO2 equivalent) of 2008 in Belgium to that in Bosnia and Herzegovina?
Make the answer very short. 4.31. What is the ratio of the Emissions (1000 metric ton of CO2 equivalent) in 1990 in Belgium to that in Botswana?
Your response must be concise. 1.21. What is the ratio of the Emissions (1000 metric ton of CO2 equivalent) of 2000 in Belgium to that in Botswana?
Provide a succinct answer. 2.02. What is the ratio of the Emissions (1000 metric ton of CO2 equivalent) in 2005 in Belgium to that in Botswana?
Provide a succinct answer. 1.48. What is the ratio of the Emissions (1000 metric ton of CO2 equivalent) in 2008 in Belgium to that in Botswana?
Make the answer very short. 1.78. What is the ratio of the Emissions (1000 metric ton of CO2 equivalent) in 1990 in Benin to that in Bolivia?
Make the answer very short. 0.16. What is the ratio of the Emissions (1000 metric ton of CO2 equivalent) in 2000 in Benin to that in Bolivia?
Keep it short and to the point. 0.2. What is the ratio of the Emissions (1000 metric ton of CO2 equivalent) of 2005 in Benin to that in Bolivia?
Give a very brief answer. 0.19. What is the ratio of the Emissions (1000 metric ton of CO2 equivalent) in 2008 in Benin to that in Bolivia?
Keep it short and to the point. 0.32. What is the ratio of the Emissions (1000 metric ton of CO2 equivalent) of 1990 in Benin to that in Bosnia and Herzegovina?
Your answer should be very brief. 1.16. What is the ratio of the Emissions (1000 metric ton of CO2 equivalent) of 2000 in Benin to that in Bosnia and Herzegovina?
Give a very brief answer. 2.09. What is the ratio of the Emissions (1000 metric ton of CO2 equivalent) of 2005 in Benin to that in Bosnia and Herzegovina?
Give a very brief answer. 1.71. What is the ratio of the Emissions (1000 metric ton of CO2 equivalent) in 2008 in Benin to that in Bosnia and Herzegovina?
Your response must be concise. 2.54. What is the ratio of the Emissions (1000 metric ton of CO2 equivalent) in 1990 in Benin to that in Botswana?
Provide a short and direct response. 0.34. What is the ratio of the Emissions (1000 metric ton of CO2 equivalent) of 2000 in Benin to that in Botswana?
Offer a terse response. 0.65. What is the ratio of the Emissions (1000 metric ton of CO2 equivalent) of 2005 in Benin to that in Botswana?
Make the answer very short. 0.52. What is the ratio of the Emissions (1000 metric ton of CO2 equivalent) of 2008 in Benin to that in Botswana?
Your response must be concise. 1.05. What is the ratio of the Emissions (1000 metric ton of CO2 equivalent) in 1990 in Bolivia to that in Bosnia and Herzegovina?
Offer a very short reply. 7.13. What is the ratio of the Emissions (1000 metric ton of CO2 equivalent) in 2000 in Bolivia to that in Bosnia and Herzegovina?
Make the answer very short. 10.65. What is the ratio of the Emissions (1000 metric ton of CO2 equivalent) of 2005 in Bolivia to that in Bosnia and Herzegovina?
Offer a terse response. 8.97. What is the ratio of the Emissions (1000 metric ton of CO2 equivalent) of 2008 in Bolivia to that in Bosnia and Herzegovina?
Your answer should be very brief. 7.93. What is the ratio of the Emissions (1000 metric ton of CO2 equivalent) in 1990 in Bolivia to that in Botswana?
Offer a very short reply. 2.09. What is the ratio of the Emissions (1000 metric ton of CO2 equivalent) in 2000 in Bolivia to that in Botswana?
Offer a very short reply. 3.28. What is the ratio of the Emissions (1000 metric ton of CO2 equivalent) of 2005 in Bolivia to that in Botswana?
Your answer should be very brief. 2.71. What is the ratio of the Emissions (1000 metric ton of CO2 equivalent) in 2008 in Bolivia to that in Botswana?
Offer a terse response. 3.28. What is the ratio of the Emissions (1000 metric ton of CO2 equivalent) in 1990 in Bosnia and Herzegovina to that in Botswana?
Provide a short and direct response. 0.29. What is the ratio of the Emissions (1000 metric ton of CO2 equivalent) of 2000 in Bosnia and Herzegovina to that in Botswana?
Provide a succinct answer. 0.31. What is the ratio of the Emissions (1000 metric ton of CO2 equivalent) of 2005 in Bosnia and Herzegovina to that in Botswana?
Offer a terse response. 0.3. What is the ratio of the Emissions (1000 metric ton of CO2 equivalent) of 2008 in Bosnia and Herzegovina to that in Botswana?
Ensure brevity in your answer.  0.41. What is the difference between the highest and the second highest Emissions (1000 metric ton of CO2 equivalent) of 1990?
Make the answer very short. 2825.3. What is the difference between the highest and the second highest Emissions (1000 metric ton of CO2 equivalent) of 2000?
Offer a terse response. 2249.3. What is the difference between the highest and the second highest Emissions (1000 metric ton of CO2 equivalent) in 2005?
Your answer should be very brief. 2268.1. What is the difference between the highest and the second highest Emissions (1000 metric ton of CO2 equivalent) in 2008?
Offer a terse response. 1895.5. What is the difference between the highest and the lowest Emissions (1000 metric ton of CO2 equivalent) of 1990?
Offer a terse response. 1.27e+04. What is the difference between the highest and the lowest Emissions (1000 metric ton of CO2 equivalent) of 2000?
Your response must be concise. 9613.1. What is the difference between the highest and the lowest Emissions (1000 metric ton of CO2 equivalent) of 2005?
Your answer should be compact. 9254.6. What is the difference between the highest and the lowest Emissions (1000 metric ton of CO2 equivalent) of 2008?
Offer a terse response. 8868.1. 